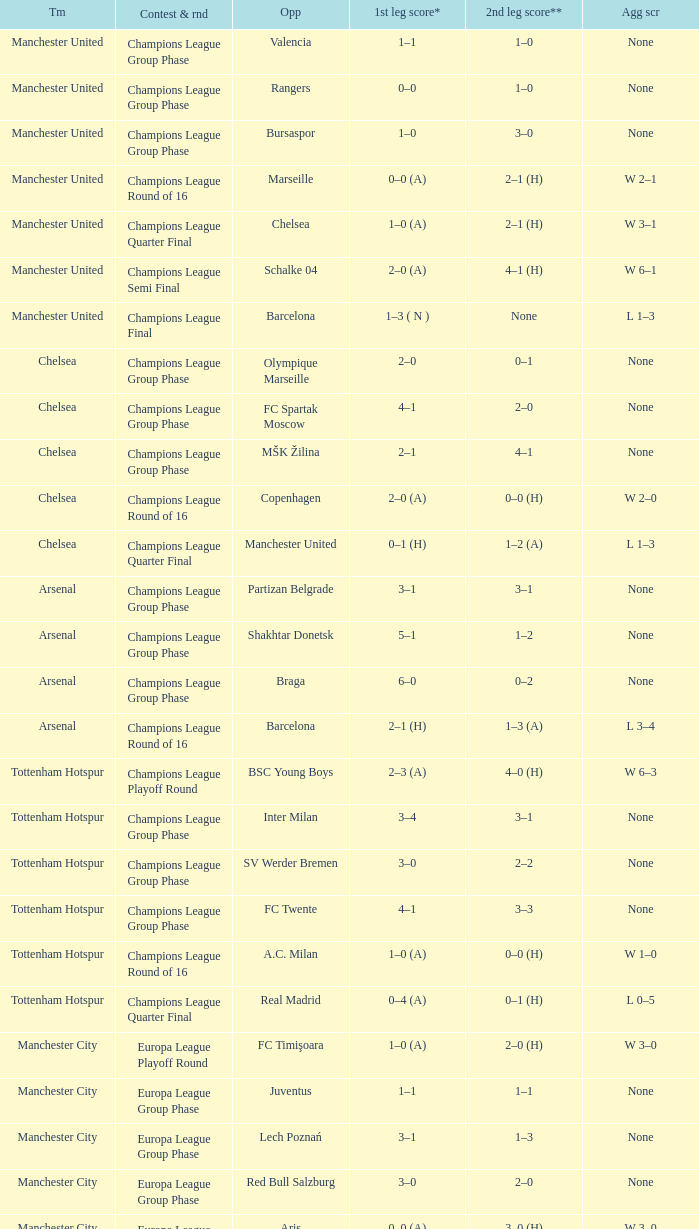How many goals did each one of the teams score in the first leg of the match between Liverpool and Trabzonspor? 1–0 (H). 